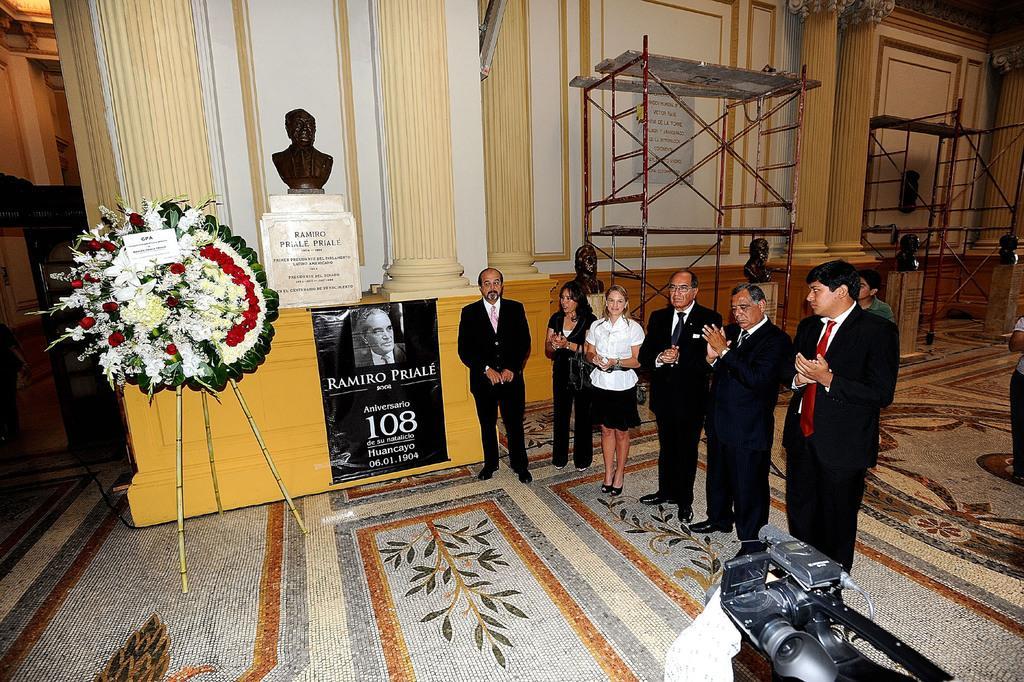Please provide a concise description of this image. In the image in the center, we can see a few people are standing. At the bottom of the image there is a camera. In the background there is a wooden wall, carpet, stand, banners, poles, one flower bouquet, sculptures and a few other objects. 